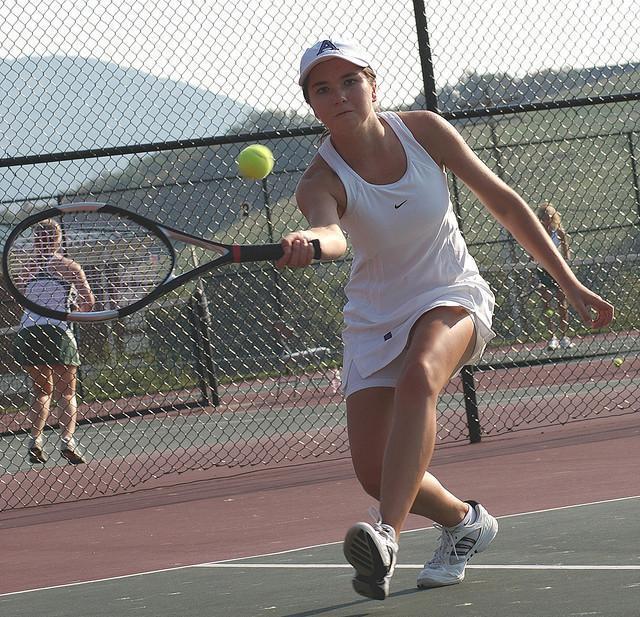How many people are there?
Give a very brief answer. 3. How many elephants are near the rocks?
Give a very brief answer. 0. 